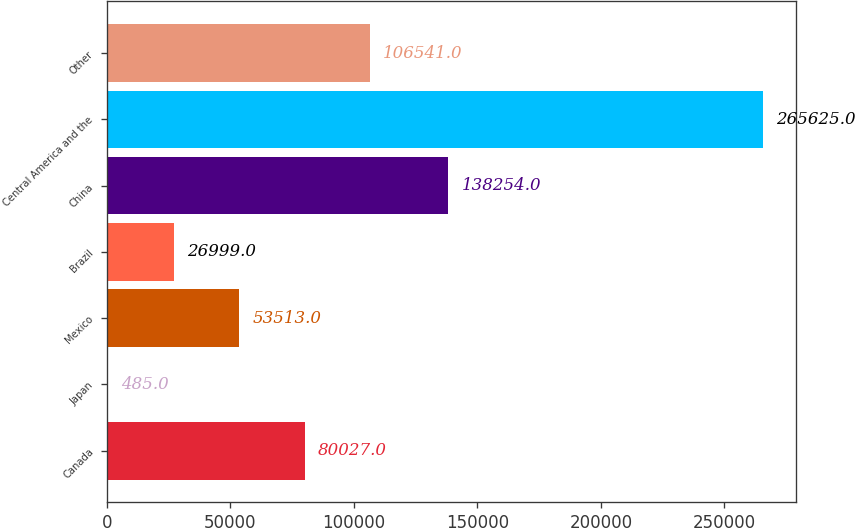<chart> <loc_0><loc_0><loc_500><loc_500><bar_chart><fcel>Canada<fcel>Japan<fcel>Mexico<fcel>Brazil<fcel>China<fcel>Central America and the<fcel>Other<nl><fcel>80027<fcel>485<fcel>53513<fcel>26999<fcel>138254<fcel>265625<fcel>106541<nl></chart> 